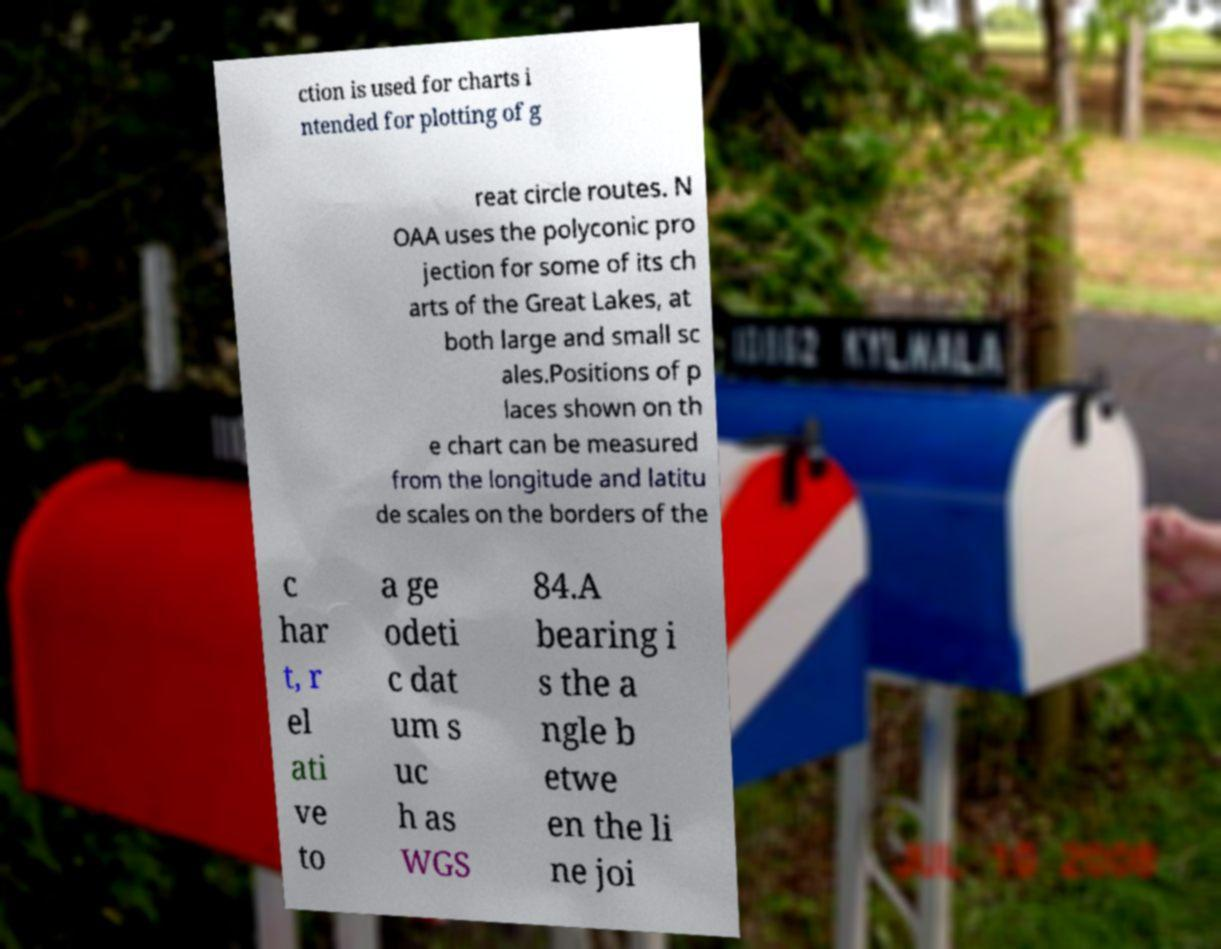Can you read and provide the text displayed in the image?This photo seems to have some interesting text. Can you extract and type it out for me? ction is used for charts i ntended for plotting of g reat circle routes. N OAA uses the polyconic pro jection for some of its ch arts of the Great Lakes, at both large and small sc ales.Positions of p laces shown on th e chart can be measured from the longitude and latitu de scales on the borders of the c har t, r el ati ve to a ge odeti c dat um s uc h as WGS 84.A bearing i s the a ngle b etwe en the li ne joi 